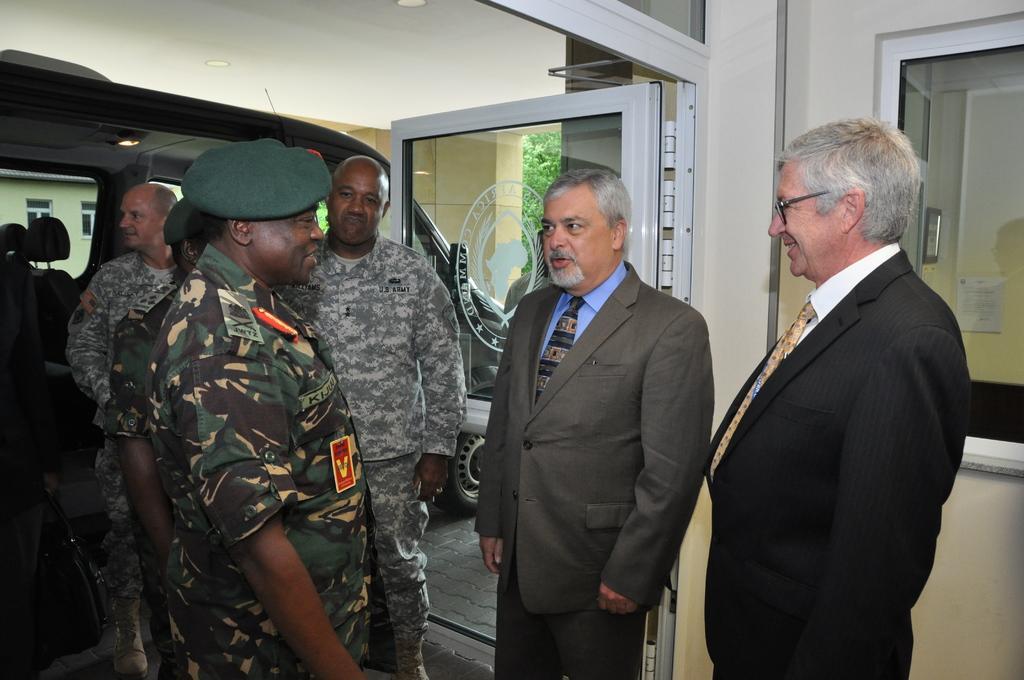In one or two sentences, can you explain what this image depicts? In this image there is a person wearing a uniform and a cap. He is standing on the floor. Before him there is a person wearing a blazer and tie. Right side there is a person wearing blazer, tie and spectacles. There are people on the floor. Right side there is a wall having a door and a window. Left side there is a vehicle. There are pillars attached to the roof. Behind the pillars there are trees. 